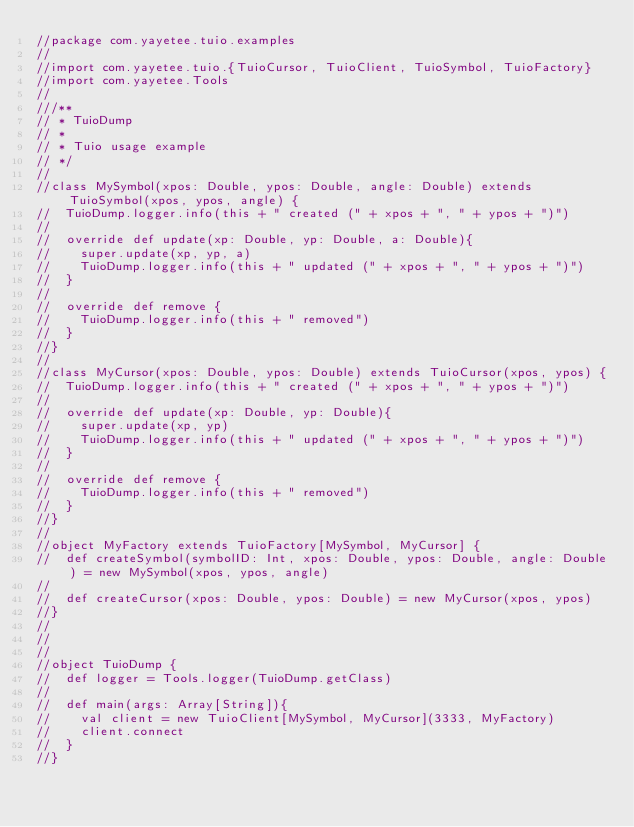Convert code to text. <code><loc_0><loc_0><loc_500><loc_500><_Scala_>//package com.yayetee.tuio.examples
//
//import com.yayetee.tuio.{TuioCursor, TuioClient, TuioSymbol, TuioFactory}
//import com.yayetee.Tools
//
///**
// * TuioDump
// *
// * Tuio usage example
// */
//
//class MySymbol(xpos: Double, ypos: Double, angle: Double) extends TuioSymbol(xpos, ypos, angle) {
//	TuioDump.logger.info(this + " created (" + xpos + ", " + ypos + ")")
//
//	override def update(xp: Double, yp: Double, a: Double){
//		super.update(xp, yp, a)
//		TuioDump.logger.info(this + " updated (" + xpos + ", " + ypos + ")")
//	}
//
//	override def remove {
//		TuioDump.logger.info(this + " removed")
//	}
//}
//
//class MyCursor(xpos: Double, ypos: Double) extends TuioCursor(xpos, ypos) {
//	TuioDump.logger.info(this + " created (" + xpos + ", " + ypos + ")")
//
//	override def update(xp: Double, yp: Double){
//		super.update(xp, yp)
//		TuioDump.logger.info(this + " updated (" + xpos + ", " + ypos + ")")
//	}
//
//	override def remove {
//		TuioDump.logger.info(this + " removed")
//	}
//}
//
//object MyFactory extends TuioFactory[MySymbol, MyCursor] {
//	def createSymbol(symbolID: Int, xpos: Double, ypos: Double, angle: Double) = new MySymbol(xpos, ypos, angle)
//
//	def createCursor(xpos: Double, ypos: Double) = new MyCursor(xpos, ypos)
//}
//
//
//
//object TuioDump {
//	def logger = Tools.logger(TuioDump.getClass)
//
//	def main(args: Array[String]){
//		val client = new TuioClient[MySymbol, MyCursor](3333, MyFactory)
//		client.connect
//	}
//}
</code> 